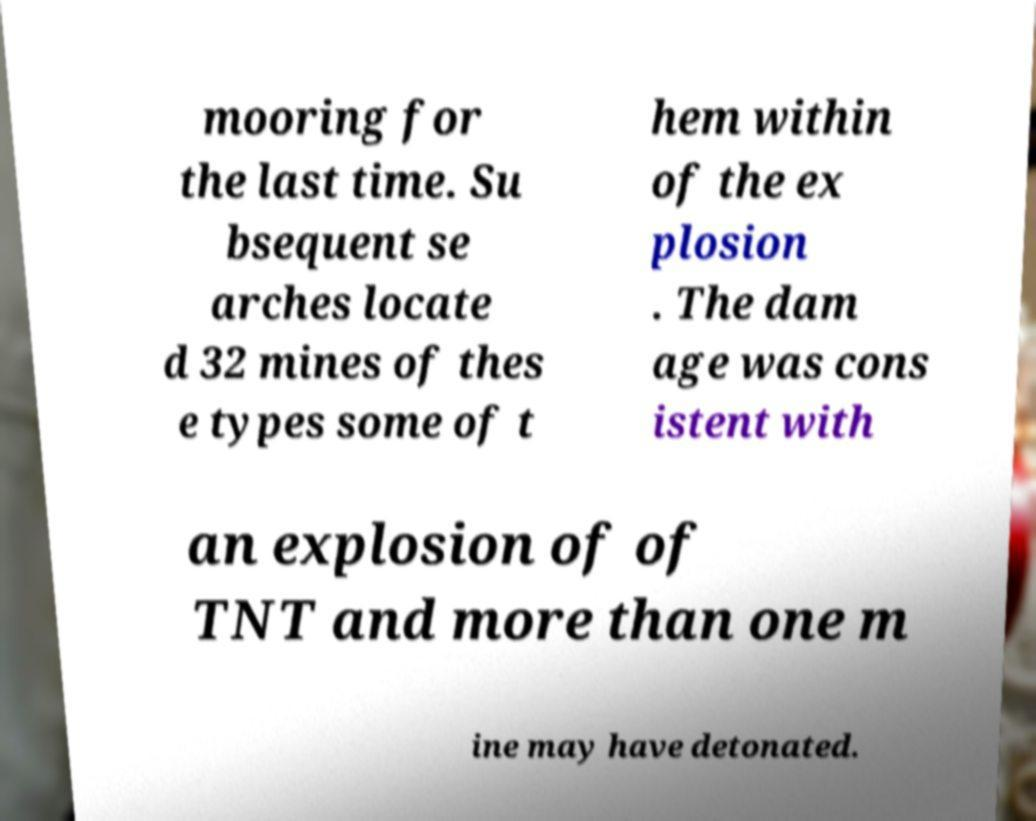Could you extract and type out the text from this image? mooring for the last time. Su bsequent se arches locate d 32 mines of thes e types some of t hem within of the ex plosion . The dam age was cons istent with an explosion of of TNT and more than one m ine may have detonated. 